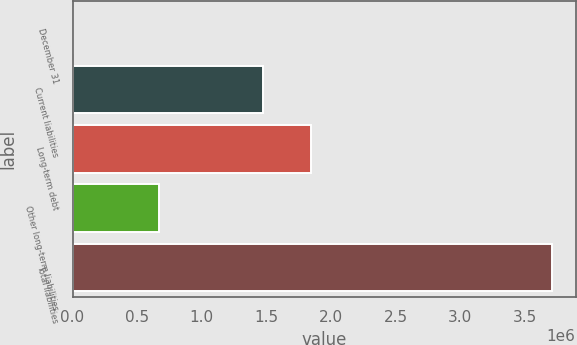Convert chart. <chart><loc_0><loc_0><loc_500><loc_500><bar_chart><fcel>December 31<fcel>Current liabilities<fcel>Long-term debt<fcel>Other long-term liabilities<fcel>Total liabilities<nl><fcel>2012<fcel>1.47111e+06<fcel>1.84156e+06<fcel>668732<fcel>3.70647e+06<nl></chart> 